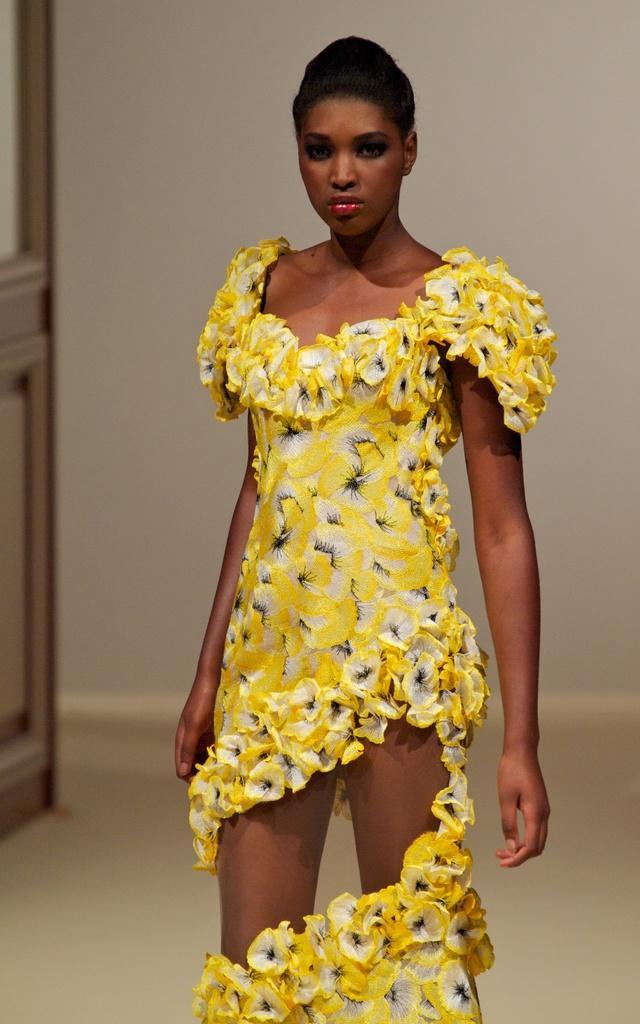Can you describe this image briefly? There is a woman standing and wore yellow dress. In the background we can see wall and object. 